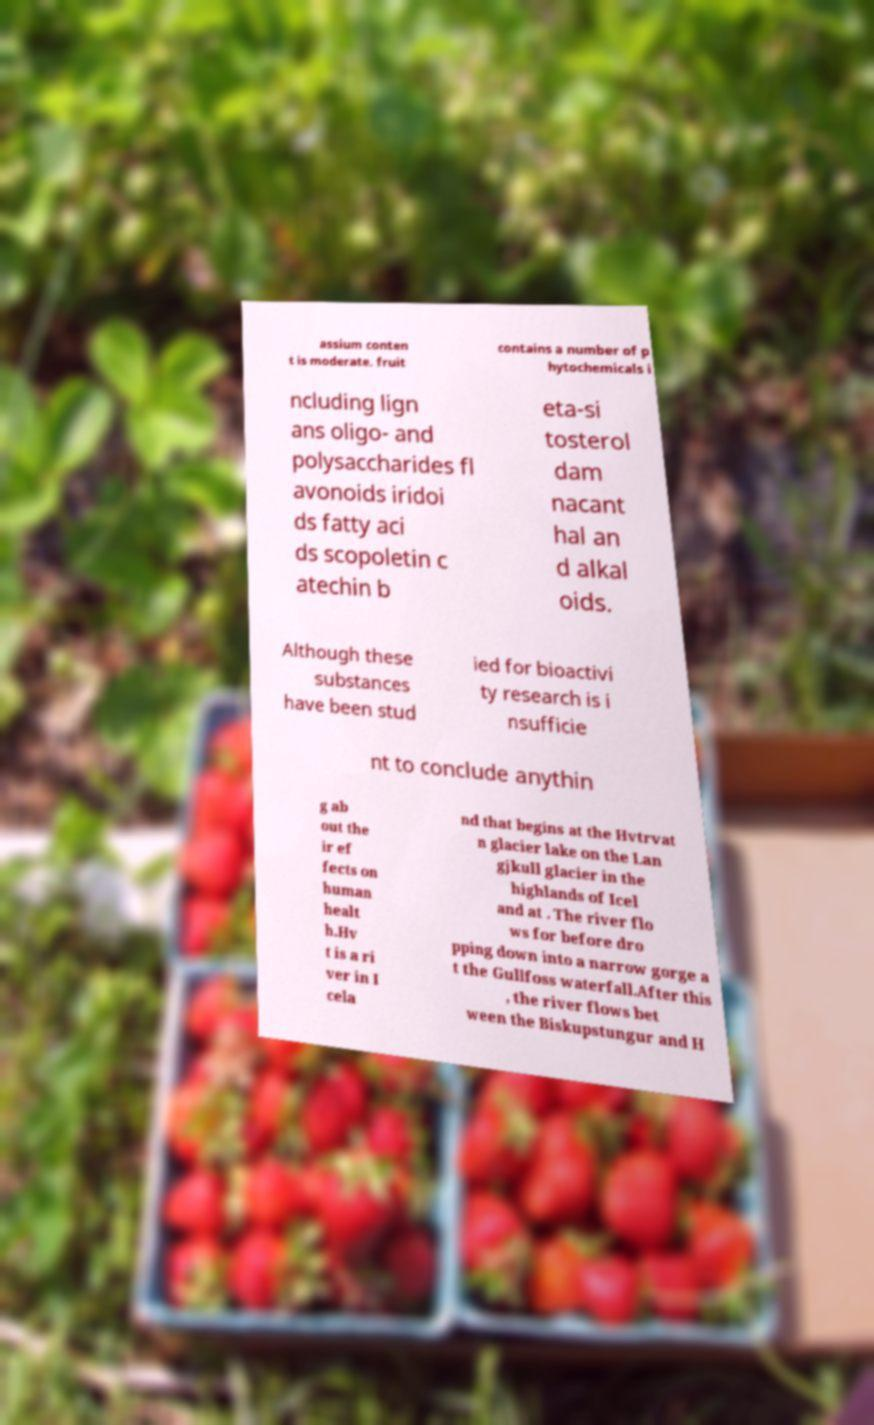Please read and relay the text visible in this image. What does it say? assium conten t is moderate. fruit contains a number of p hytochemicals i ncluding lign ans oligo- and polysaccharides fl avonoids iridoi ds fatty aci ds scopoletin c atechin b eta-si tosterol dam nacant hal an d alkal oids. Although these substances have been stud ied for bioactivi ty research is i nsufficie nt to conclude anythin g ab out the ir ef fects on human healt h.Hv t is a ri ver in I cela nd that begins at the Hvtrvat n glacier lake on the Lan gjkull glacier in the highlands of Icel and at . The river flo ws for before dro pping down into a narrow gorge a t the Gullfoss waterfall.After this , the river flows bet ween the Biskupstungur and H 